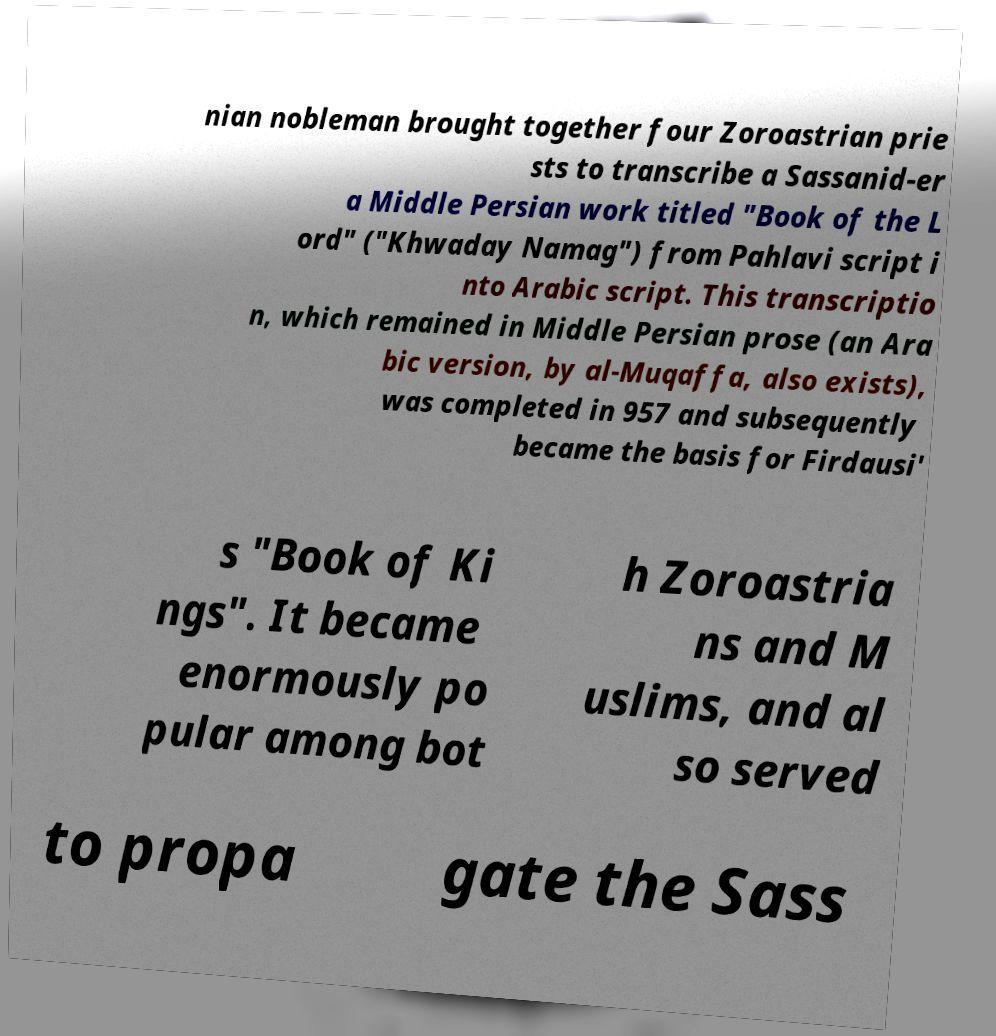Could you extract and type out the text from this image? nian nobleman brought together four Zoroastrian prie sts to transcribe a Sassanid-er a Middle Persian work titled "Book of the L ord" ("Khwaday Namag") from Pahlavi script i nto Arabic script. This transcriptio n, which remained in Middle Persian prose (an Ara bic version, by al-Muqaffa, also exists), was completed in 957 and subsequently became the basis for Firdausi' s "Book of Ki ngs". It became enormously po pular among bot h Zoroastria ns and M uslims, and al so served to propa gate the Sass 